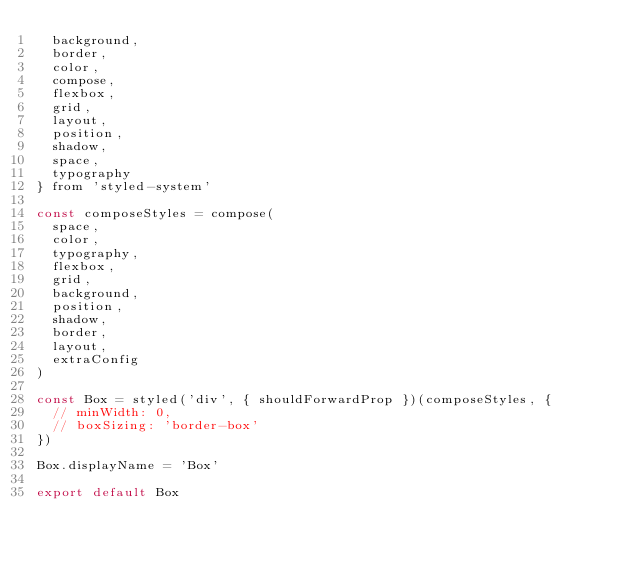<code> <loc_0><loc_0><loc_500><loc_500><_JavaScript_>  background,
  border,
  color,
  compose,
  flexbox,
  grid,
  layout,
  position,
  shadow,
  space,
  typography
} from 'styled-system'

const composeStyles = compose(
  space,
  color,
  typography,
  flexbox,
  grid,
  background,
  position,
  shadow,
  border,
  layout,
  extraConfig
)

const Box = styled('div', { shouldForwardProp })(composeStyles, {
  // minWidth: 0,
  // boxSizing: 'border-box'
})

Box.displayName = 'Box'

export default Box
</code> 